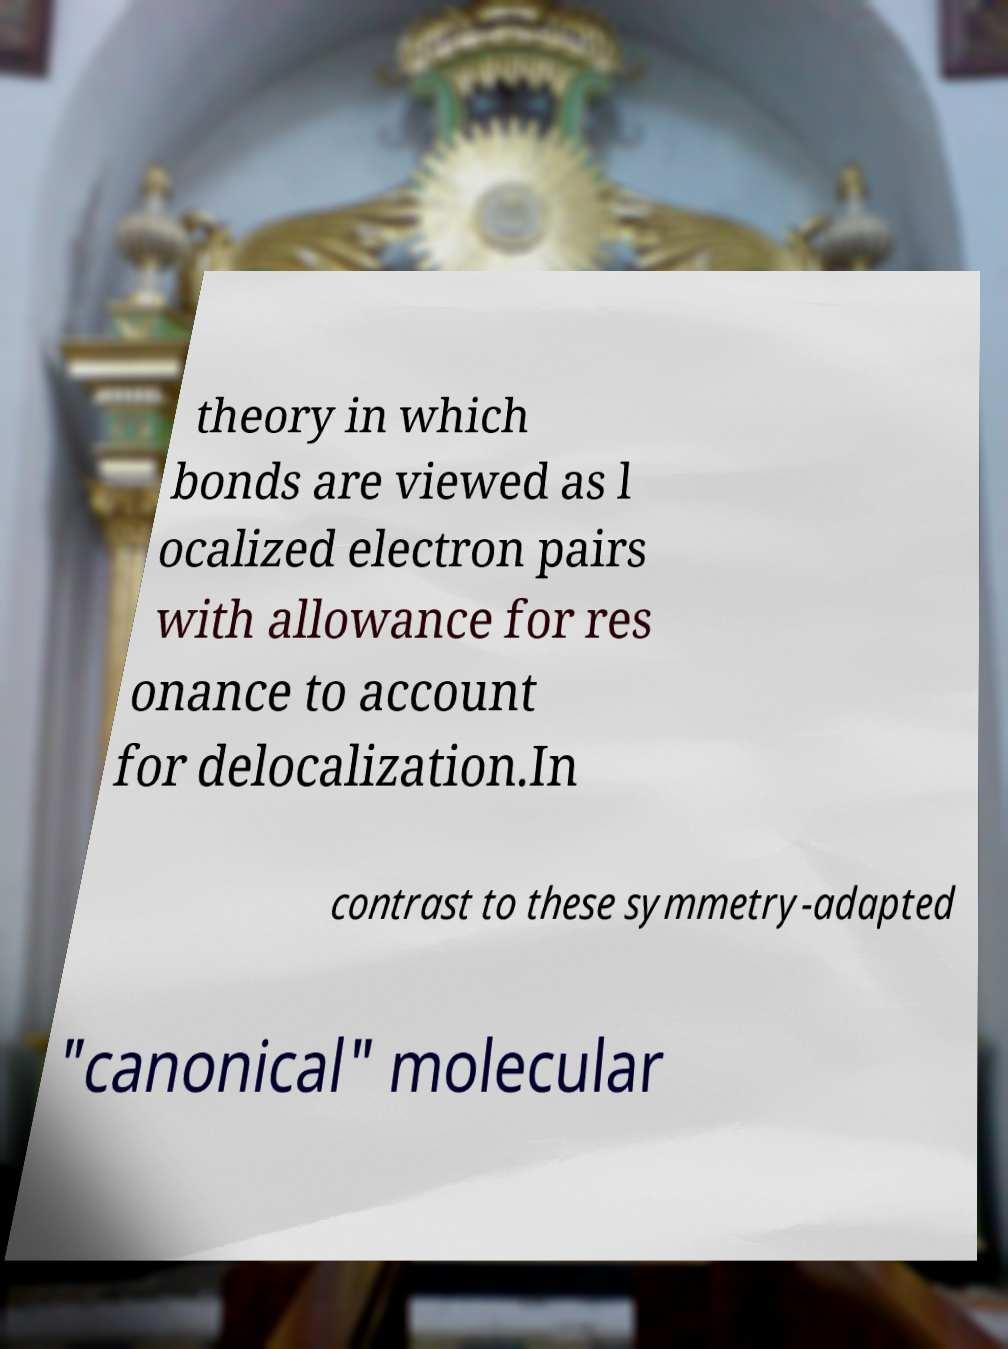Can you accurately transcribe the text from the provided image for me? theory in which bonds are viewed as l ocalized electron pairs with allowance for res onance to account for delocalization.In contrast to these symmetry-adapted "canonical" molecular 